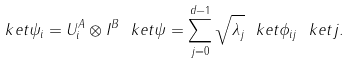<formula> <loc_0><loc_0><loc_500><loc_500>\ k e t { \psi _ { i } } = U _ { i } ^ { A } \otimes I ^ { B } \ k e t { \psi } = \sum _ { j = 0 } ^ { d - 1 } \sqrt { \lambda _ { j } } \ k e t { \phi _ { i j } } \ k e t { j } .</formula> 